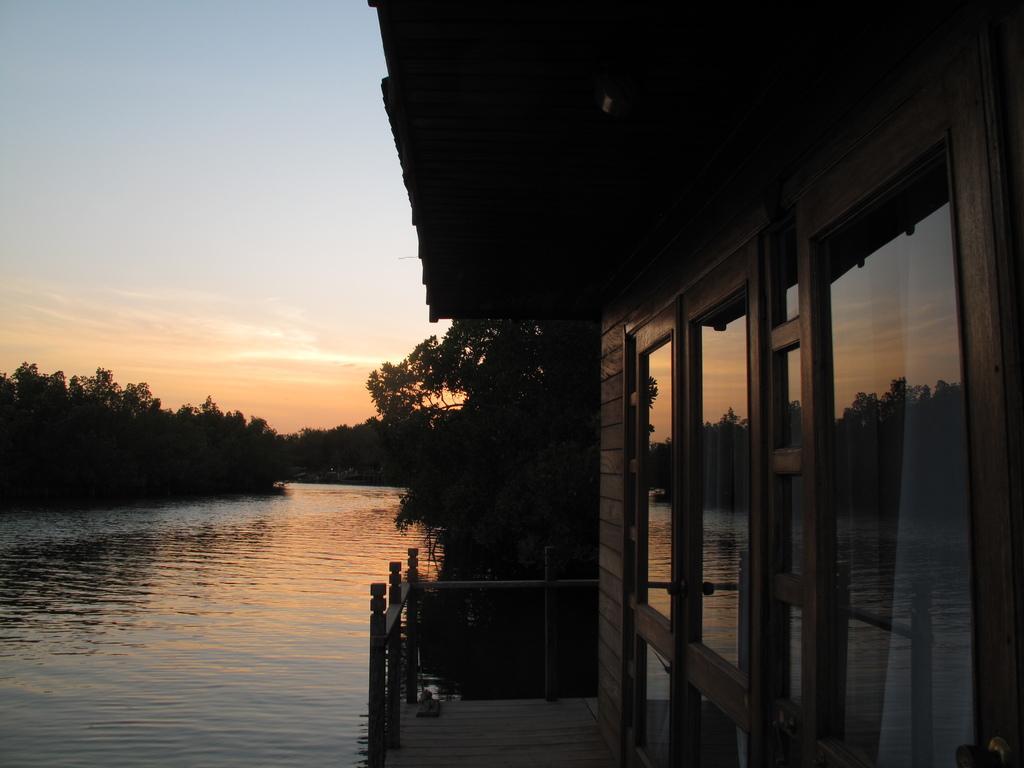Please provide a concise description of this image. On the right side, there is a platform arranged in the water. This platform is having a roof, a fence and windows. In the background, there are trees and there are clouds in the blue sky. 